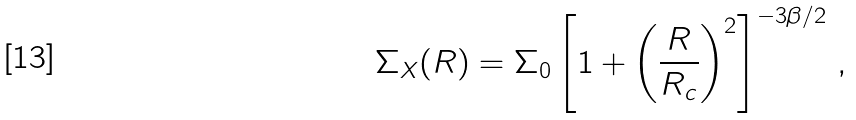Convert formula to latex. <formula><loc_0><loc_0><loc_500><loc_500>\Sigma _ { X } ( R ) = \Sigma _ { 0 } \left [ 1 + \left ( \frac { R } { R _ { c } } \right ) ^ { 2 } \right ] ^ { - 3 \beta / 2 } \, ,</formula> 